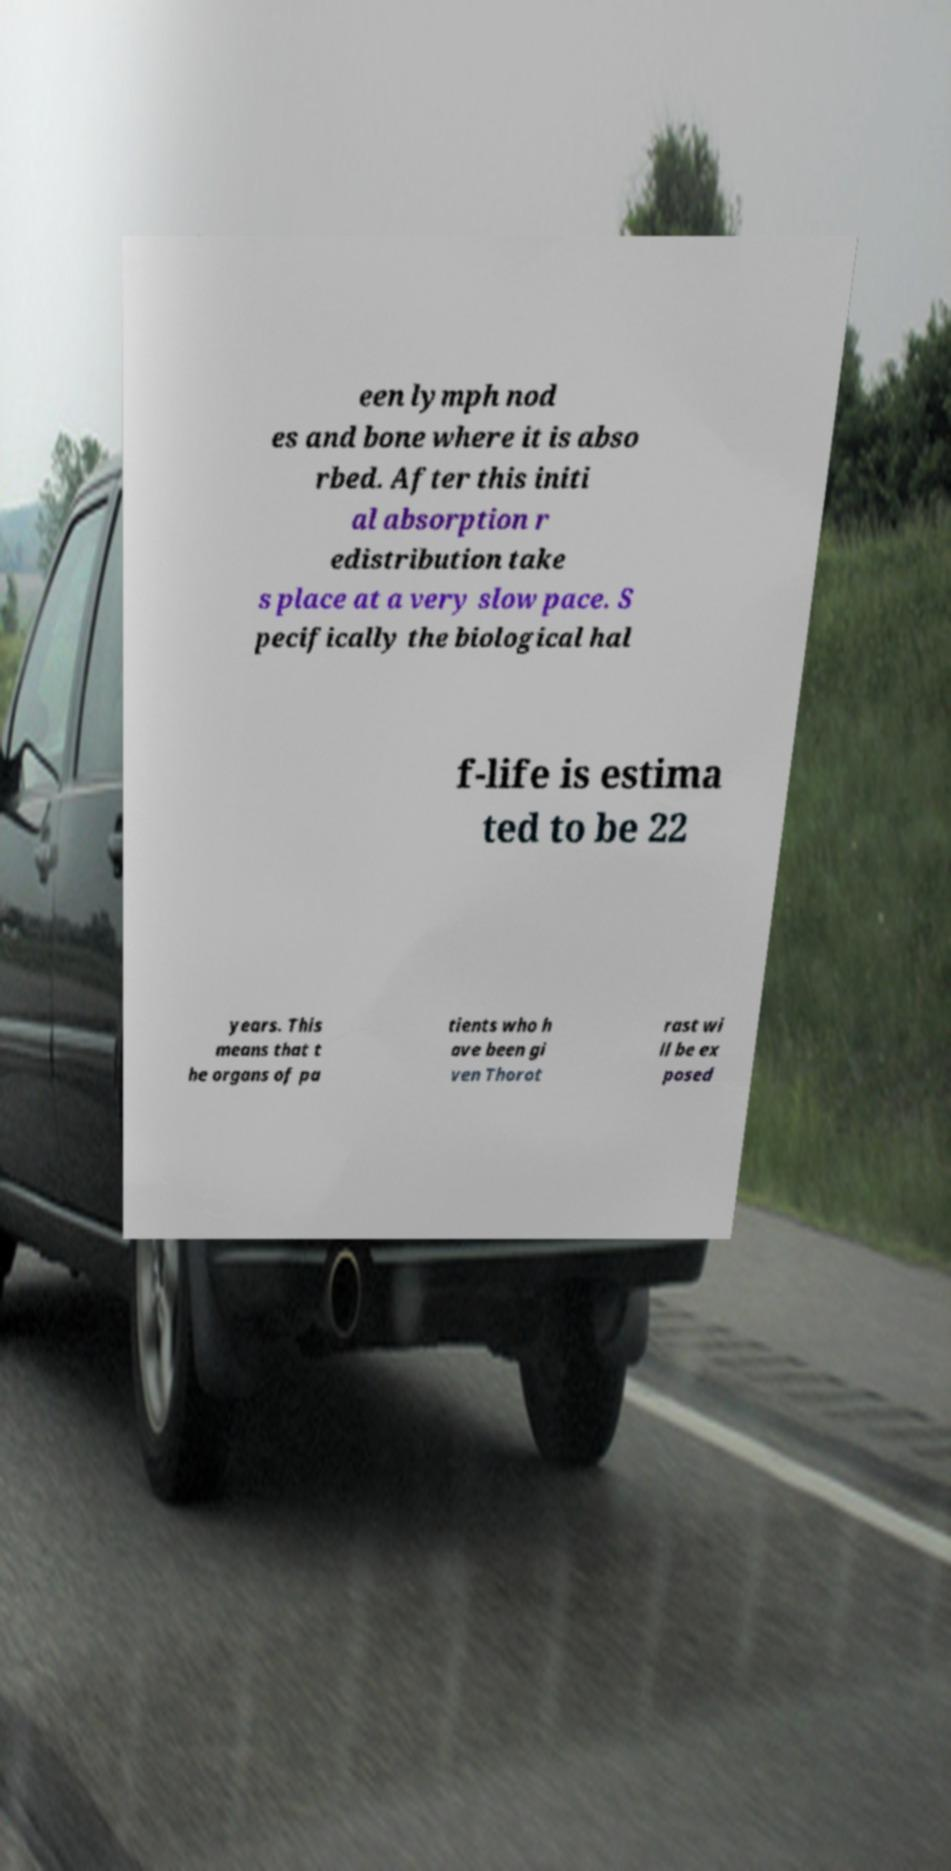Please read and relay the text visible in this image. What does it say? een lymph nod es and bone where it is abso rbed. After this initi al absorption r edistribution take s place at a very slow pace. S pecifically the biological hal f-life is estima ted to be 22 years. This means that t he organs of pa tients who h ave been gi ven Thorot rast wi ll be ex posed 